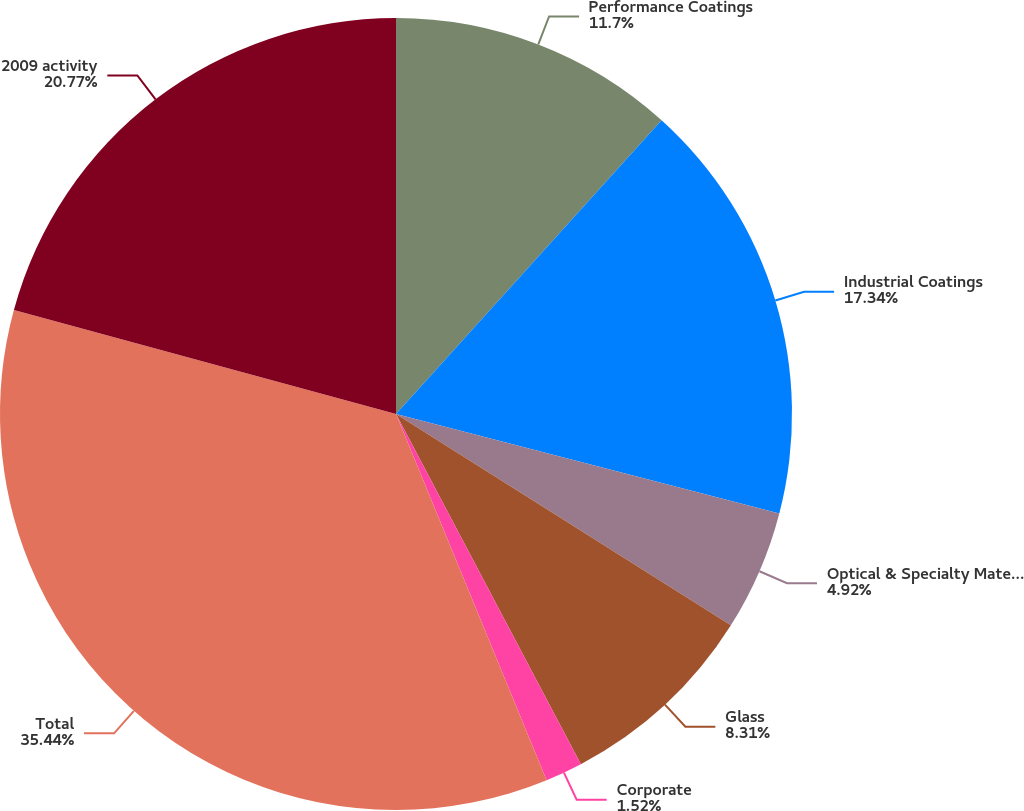Convert chart. <chart><loc_0><loc_0><loc_500><loc_500><pie_chart><fcel>Performance Coatings<fcel>Industrial Coatings<fcel>Optical & Specialty Materials<fcel>Glass<fcel>Corporate<fcel>Total<fcel>2009 activity<nl><fcel>11.7%<fcel>17.34%<fcel>4.92%<fcel>8.31%<fcel>1.52%<fcel>35.44%<fcel>20.77%<nl></chart> 